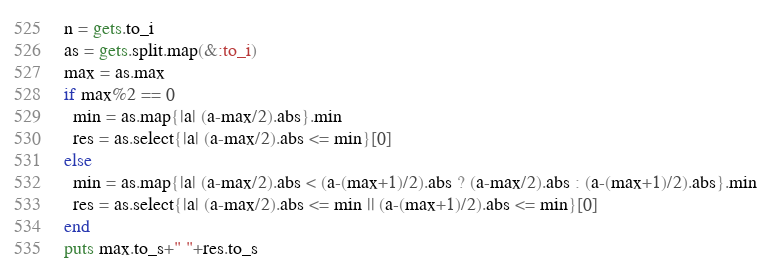Convert code to text. <code><loc_0><loc_0><loc_500><loc_500><_Ruby_>n = gets.to_i
as = gets.split.map(&:to_i)
max = as.max
if max%2 == 0 
  min = as.map{|a| (a-max/2).abs}.min 
  res = as.select{|a| (a-max/2).abs <= min}[0]
else
  min = as.map{|a| (a-max/2).abs < (a-(max+1)/2).abs ? (a-max/2).abs : (a-(max+1)/2).abs}.min 
  res = as.select{|a| (a-max/2).abs <= min || (a-(max+1)/2).abs <= min}[0]
end
puts max.to_s+" "+res.to_s
</code> 